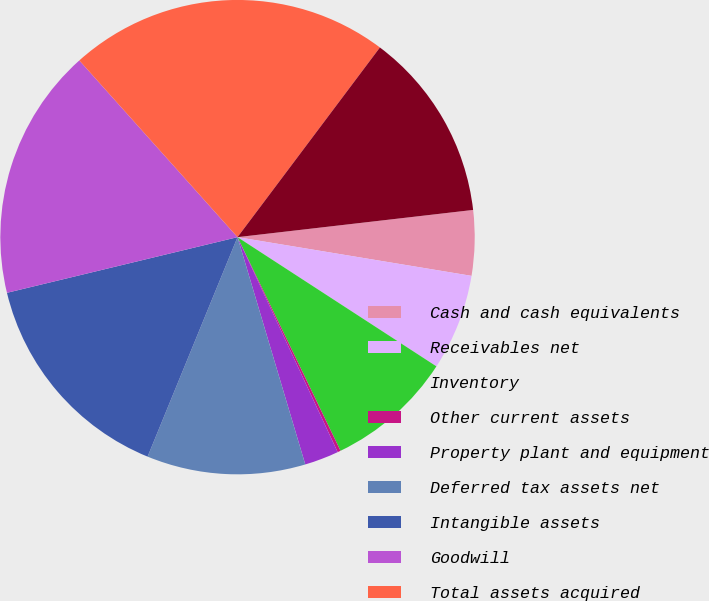<chart> <loc_0><loc_0><loc_500><loc_500><pie_chart><fcel>Cash and cash equivalents<fcel>Receivables net<fcel>Inventory<fcel>Other current assets<fcel>Property plant and equipment<fcel>Deferred tax assets net<fcel>Intangible assets<fcel>Goodwill<fcel>Total assets acquired<fcel>Total liabilities assumed<nl><fcel>4.44%<fcel>6.56%<fcel>8.68%<fcel>0.21%<fcel>2.33%<fcel>10.8%<fcel>15.04%<fcel>17.15%<fcel>21.87%<fcel>12.92%<nl></chart> 